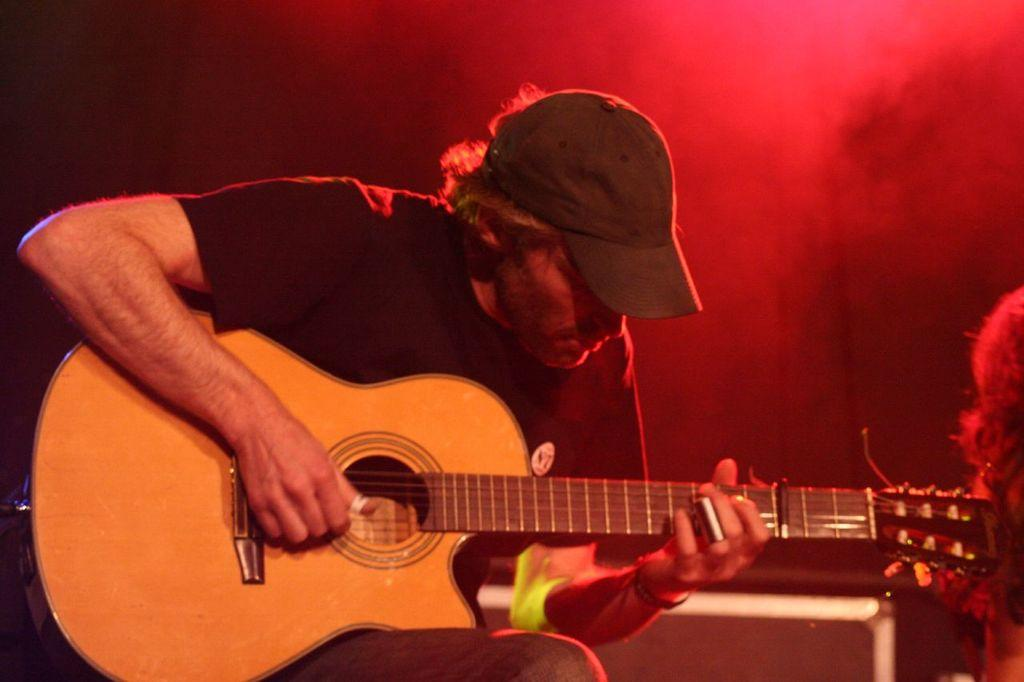Who is in the image? There is a person in the image. What is the person doing? The person is sitting and playing a guitar. Can you describe the lighting in the image? There is a red light near the person. What type of garden can be seen in the image? There is no garden present in the image. How many things are visible in the image? It is not necessary to count the number of things in the image, as we can focus on the main subjects and objects mentioned in the facts. 